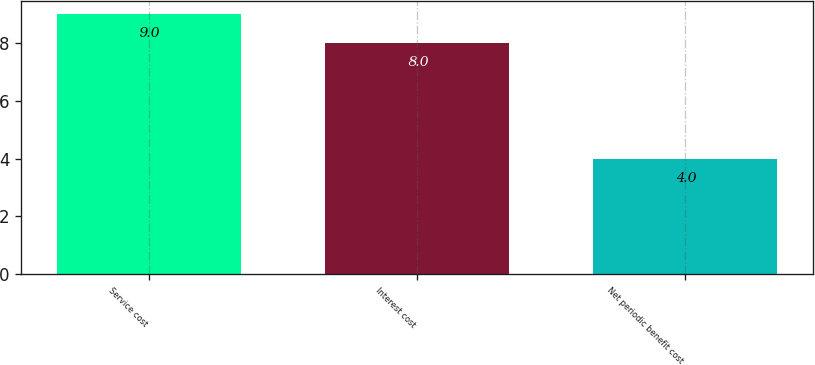Convert chart to OTSL. <chart><loc_0><loc_0><loc_500><loc_500><bar_chart><fcel>Service cost<fcel>Interest cost<fcel>Net periodic benefit cost<nl><fcel>9<fcel>8<fcel>4<nl></chart> 